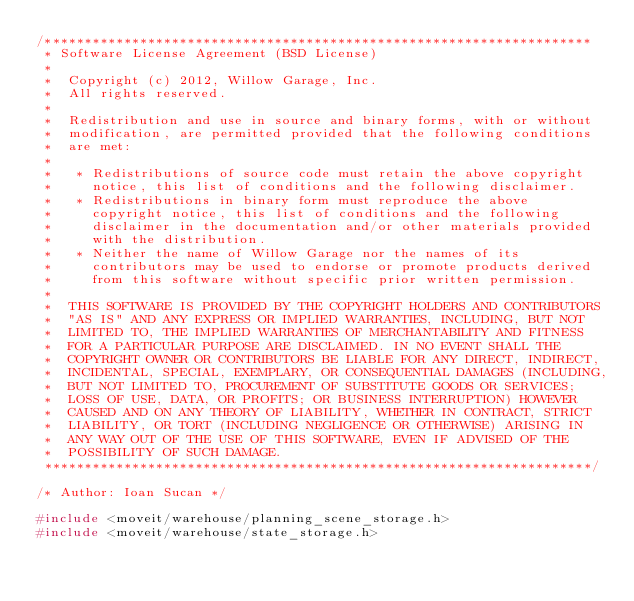Convert code to text. <code><loc_0><loc_0><loc_500><loc_500><_C++_>/*********************************************************************
 * Software License Agreement (BSD License)
 *
 *  Copyright (c) 2012, Willow Garage, Inc.
 *  All rights reserved.
 *
 *  Redistribution and use in source and binary forms, with or without
 *  modification, are permitted provided that the following conditions
 *  are met:
 *
 *   * Redistributions of source code must retain the above copyright
 *     notice, this list of conditions and the following disclaimer.
 *   * Redistributions in binary form must reproduce the above
 *     copyright notice, this list of conditions and the following
 *     disclaimer in the documentation and/or other materials provided
 *     with the distribution.
 *   * Neither the name of Willow Garage nor the names of its
 *     contributors may be used to endorse or promote products derived
 *     from this software without specific prior written permission.
 *
 *  THIS SOFTWARE IS PROVIDED BY THE COPYRIGHT HOLDERS AND CONTRIBUTORS
 *  "AS IS" AND ANY EXPRESS OR IMPLIED WARRANTIES, INCLUDING, BUT NOT
 *  LIMITED TO, THE IMPLIED WARRANTIES OF MERCHANTABILITY AND FITNESS
 *  FOR A PARTICULAR PURPOSE ARE DISCLAIMED. IN NO EVENT SHALL THE
 *  COPYRIGHT OWNER OR CONTRIBUTORS BE LIABLE FOR ANY DIRECT, INDIRECT,
 *  INCIDENTAL, SPECIAL, EXEMPLARY, OR CONSEQUENTIAL DAMAGES (INCLUDING,
 *  BUT NOT LIMITED TO, PROCUREMENT OF SUBSTITUTE GOODS OR SERVICES;
 *  LOSS OF USE, DATA, OR PROFITS; OR BUSINESS INTERRUPTION) HOWEVER
 *  CAUSED AND ON ANY THEORY OF LIABILITY, WHETHER IN CONTRACT, STRICT
 *  LIABILITY, OR TORT (INCLUDING NEGLIGENCE OR OTHERWISE) ARISING IN
 *  ANY WAY OUT OF THE USE OF THIS SOFTWARE, EVEN IF ADVISED OF THE
 *  POSSIBILITY OF SUCH DAMAGE.
 *********************************************************************/

/* Author: Ioan Sucan */

#include <moveit/warehouse/planning_scene_storage.h>
#include <moveit/warehouse/state_storage.h></code> 